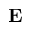<formula> <loc_0><loc_0><loc_500><loc_500>{ E }</formula> 